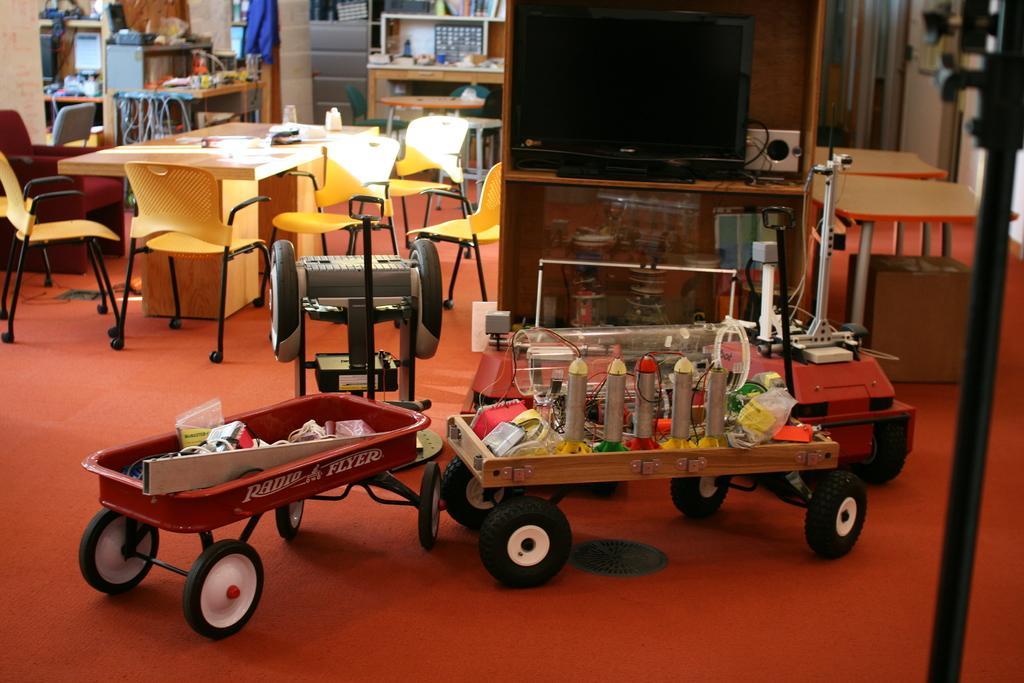How would you summarize this image in a sentence or two? In this image in the middle there is a vehicle on that there are some items. On the left, there is a table on that there are papers, around that there are many chairs and cupboards and wires. In the middle there is a television. On the right there are tables and floor. 